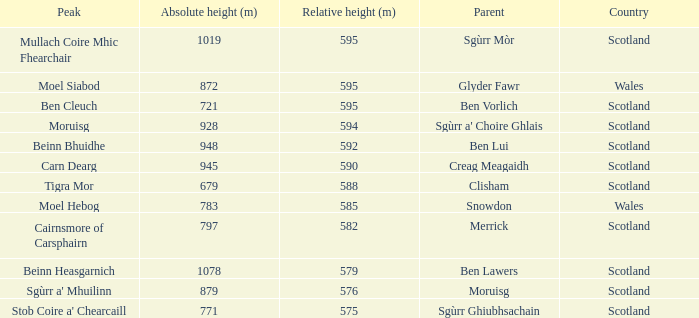What is the relative height of Scotland with Ben Vorlich as parent? 1.0. 